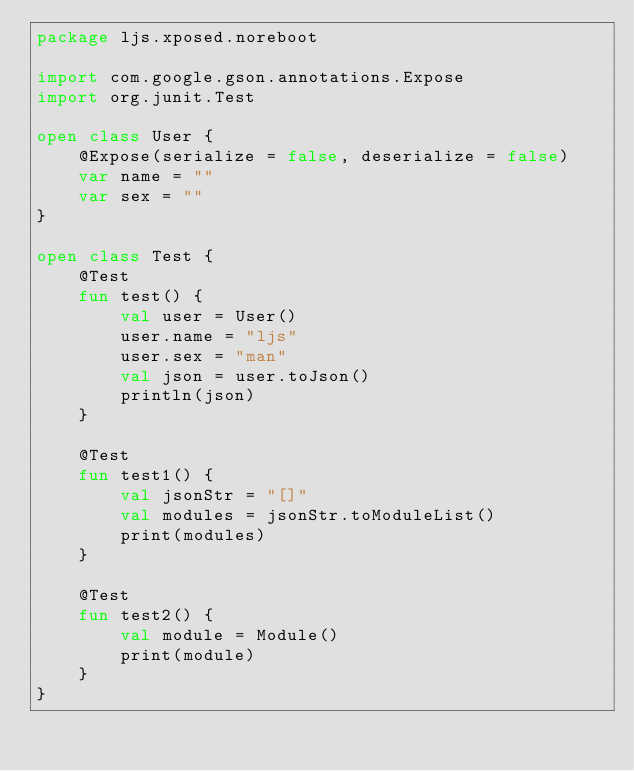Convert code to text. <code><loc_0><loc_0><loc_500><loc_500><_Kotlin_>package ljs.xposed.noreboot

import com.google.gson.annotations.Expose
import org.junit.Test

open class User {
    @Expose(serialize = false, deserialize = false)
    var name = ""
    var sex = ""
}

open class Test {
    @Test
    fun test() {
        val user = User()
        user.name = "ljs"
        user.sex = "man"
        val json = user.toJson()
        println(json)
    }

    @Test
    fun test1() {
        val jsonStr = "[]"
        val modules = jsonStr.toModuleList()
        print(modules)
    }

    @Test
    fun test2() {
        val module = Module()
        print(module)
    }
}</code> 